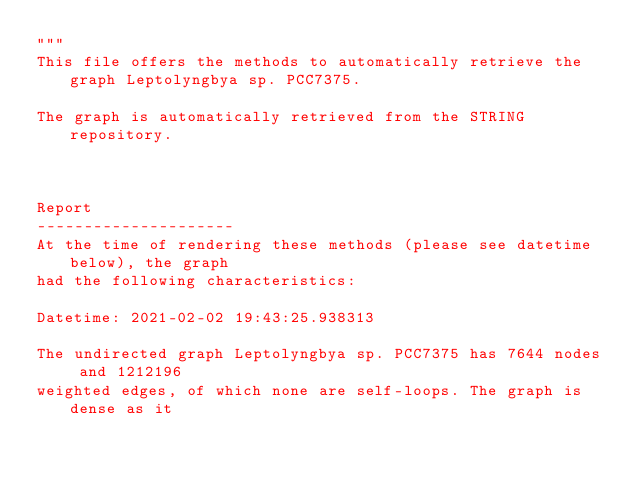Convert code to text. <code><loc_0><loc_0><loc_500><loc_500><_Python_>"""
This file offers the methods to automatically retrieve the graph Leptolyngbya sp. PCC7375.

The graph is automatically retrieved from the STRING repository. 



Report
---------------------
At the time of rendering these methods (please see datetime below), the graph
had the following characteristics:

Datetime: 2021-02-02 19:43:25.938313

The undirected graph Leptolyngbya sp. PCC7375 has 7644 nodes and 1212196
weighted edges, of which none are self-loops. The graph is dense as it</code> 